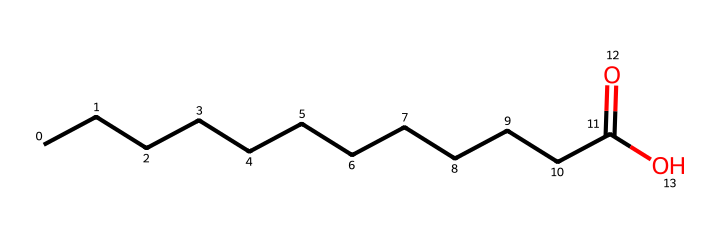What is the functional group present in this compound? The compound contains a carboxylic acid functional group, indicated by the -COOH structure. The presence of the carbonyl (C=O) and hydroxyl (-OH) groups attached to the same carbon atom defines this functional group.
Answer: carboxylic acid How many carbon atoms are in the longest chain? The SMILES notation indicates a chain of 12 carbon atoms, which can be counted directly from the 'CCCCCCCCCCCC' segment before the (C=O) group.
Answer: 12 What type of lipid is represented by this structure? This compound is a fatty acid, characterized by the long hydrocarbon chain and the carboxylic acid group at one end. Fatty acids are a type of lipid.
Answer: fatty acid What is the degree of saturation of this lipid? The absence of double bonds in the carbon chain indicates that this lipid is saturated. Saturation means all carbon atoms are fully bonded with hydrogen atoms.
Answer: saturated Is this compound likely to be soluble in water? The presence of the polar -COOH group suggests that this compound may have some solubility in water, although the long hydrophobic carbon chain generally limits overall solubility in aqueous environments.
Answer: partially soluble 